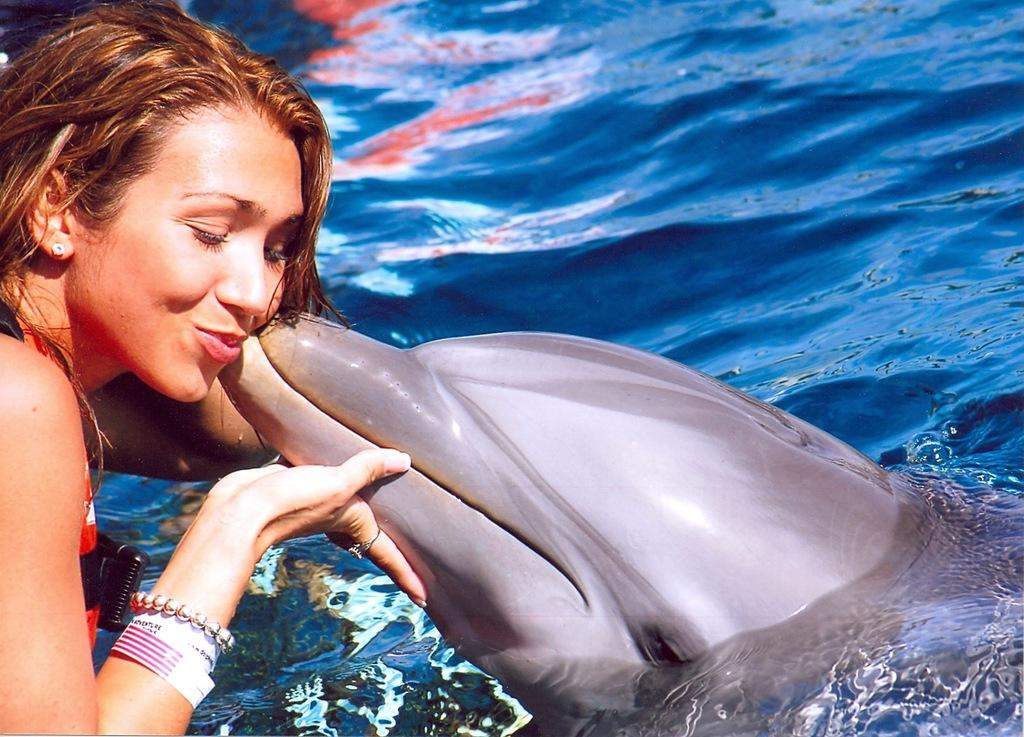Who is present in the image? There is a woman in the image. Where is the woman located in the image? The woman is at the left side corner. What is the woman holding in the image? The woman is holding a dolphin. What is the dolphin's environment in the image? The dolphin is in water. What type of brush is the woman using to paint the pie in the image? There is no brush or pie present in the image. 